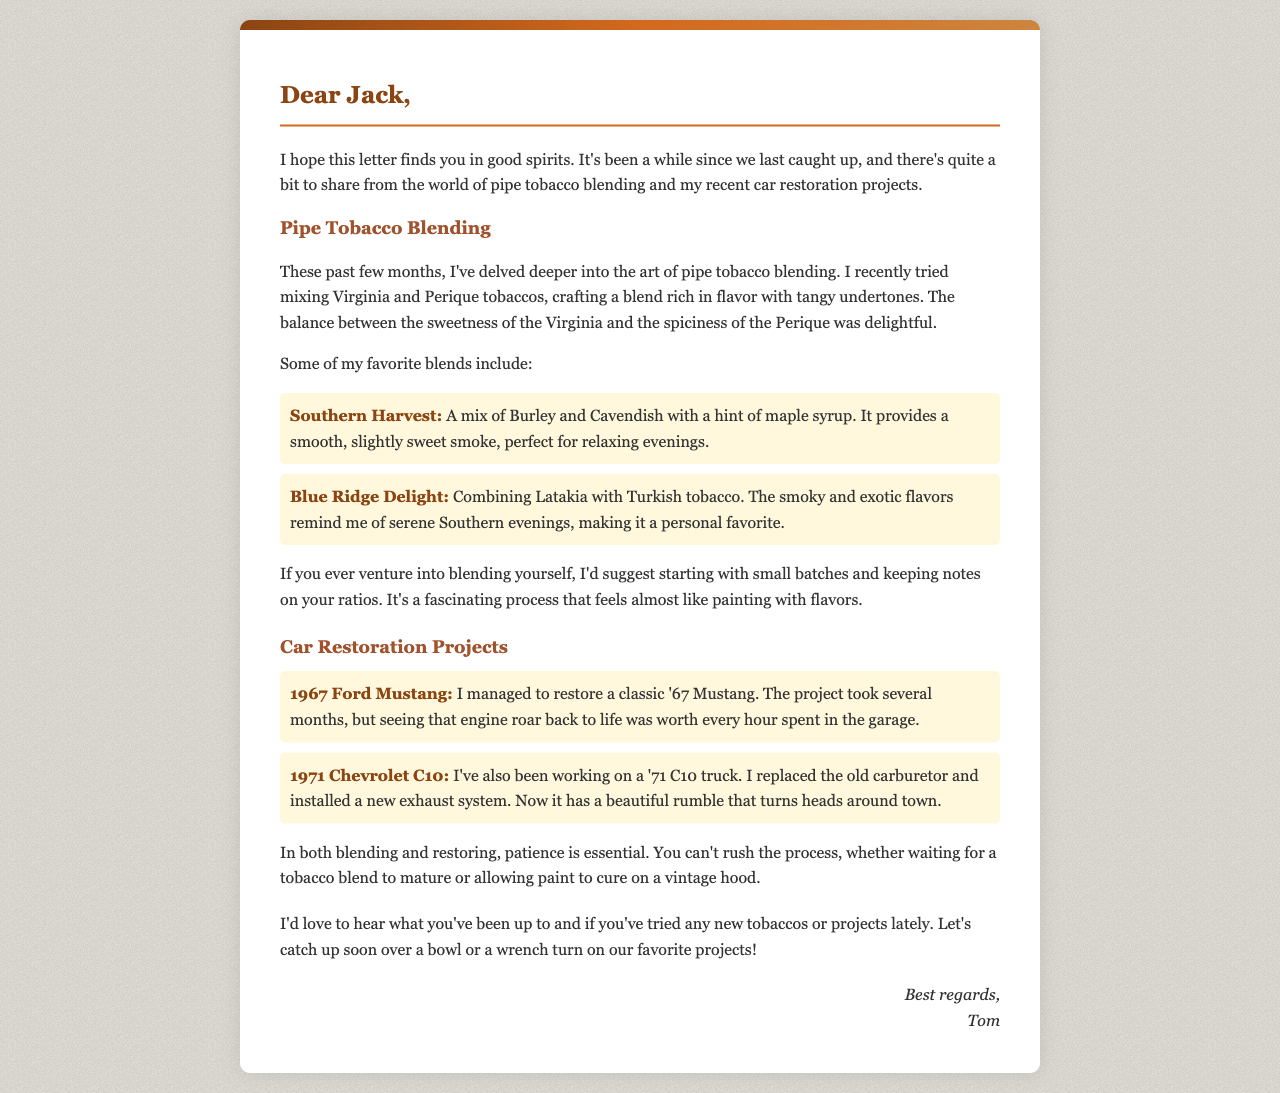what is the name of Tom's favorite tobacco blend? Tom's favorite tobacco blend mentioned in the letter is Blue Ridge Delight.
Answer: Blue Ridge Delight what year is the Ford Mustang that Tom restored? The document states that Tom restored a classic Mustang from the year 1967.
Answer: 1967 what is the main flavor profile of Southern Harvest? Southern Harvest is described as having a smooth, slightly sweet smoke with a hint of maple syrup.
Answer: smooth, slightly sweet smoke, hint of maple syrup which two tobaccos are blended in Tom's recent mix? Tom tried mixing Virginia and Perique tobaccos in his recent blending experience.
Answer: Virginia and Perique what are two major car restoration projects mentioned? Tom mentions restoring a 1967 Ford Mustang and a 1971 Chevrolet C10 as his major projects.
Answer: 1967 Ford Mustang, 1971 Chevrolet C10 what advice does Tom give regarding blending tobacco? Tom suggests starting with small batches and keeping notes on your ratios for blending tobacco.
Answer: small batches, keeping notes on your ratios what is the outcome of restoring the 1971 Chevrolet C10? After restoring the 1971 Chevrolet C10, Tom describes it having a beautiful rumble that turns heads around town.
Answer: beautiful rumble what is the overall theme of Tom's experiences shared in the letter? The overall theme revolves around Tom's passions for pipe tobacco blending and car restoration projects.
Answer: pipe tobacco blending, car restoration projects 